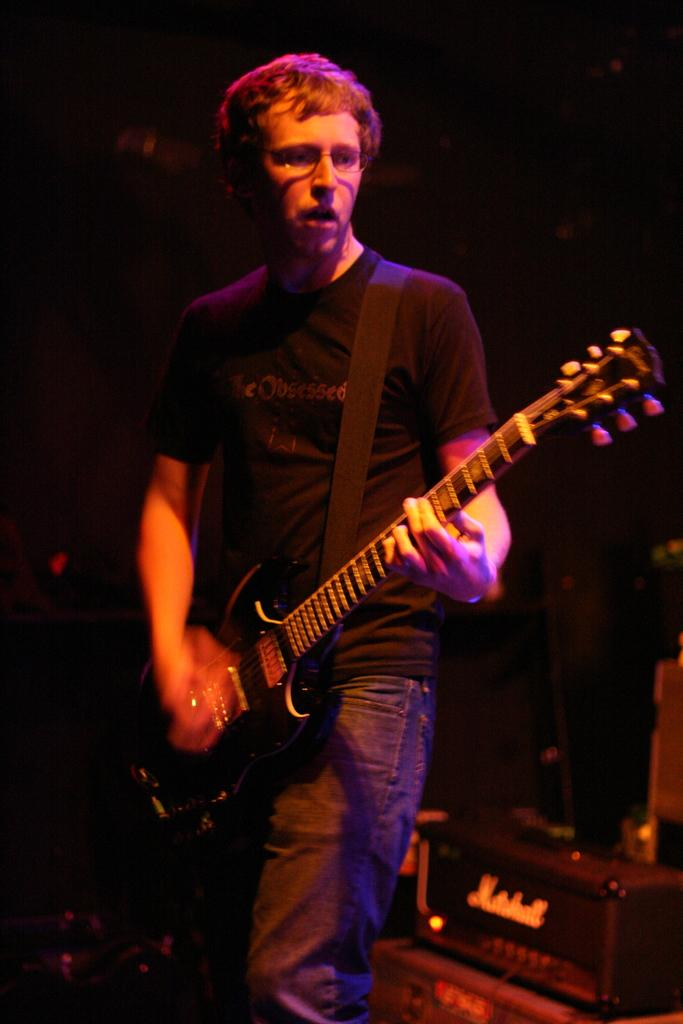What is the main subject of the image? The main subject of the image is a man. What is the man doing in the image? The man is standing in the image. What object is the man holding in the image? The man is holding a guitar in his hand. What type of mask is the man wearing in the image? There is no mask present in the image; the man is not wearing one. What type of silk material can be seen in the image? There is no silk material present in the image. 